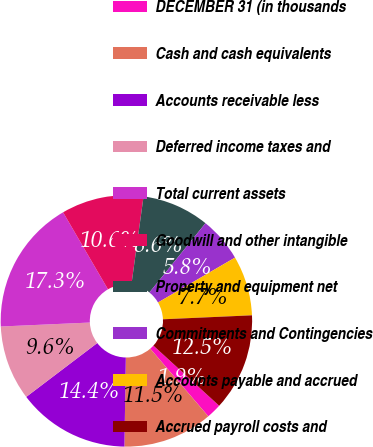Convert chart. <chart><loc_0><loc_0><loc_500><loc_500><pie_chart><fcel>DECEMBER 31 (in thousands<fcel>Cash and cash equivalents<fcel>Accounts receivable less<fcel>Deferred income taxes and<fcel>Total current assets<fcel>Goodwill and other intangible<fcel>Property and equipment net<fcel>Commitments and Contingencies<fcel>Accounts payable and accrued<fcel>Accrued payroll costs and<nl><fcel>1.92%<fcel>11.54%<fcel>14.42%<fcel>9.62%<fcel>17.31%<fcel>10.58%<fcel>8.65%<fcel>5.77%<fcel>7.69%<fcel>12.5%<nl></chart> 